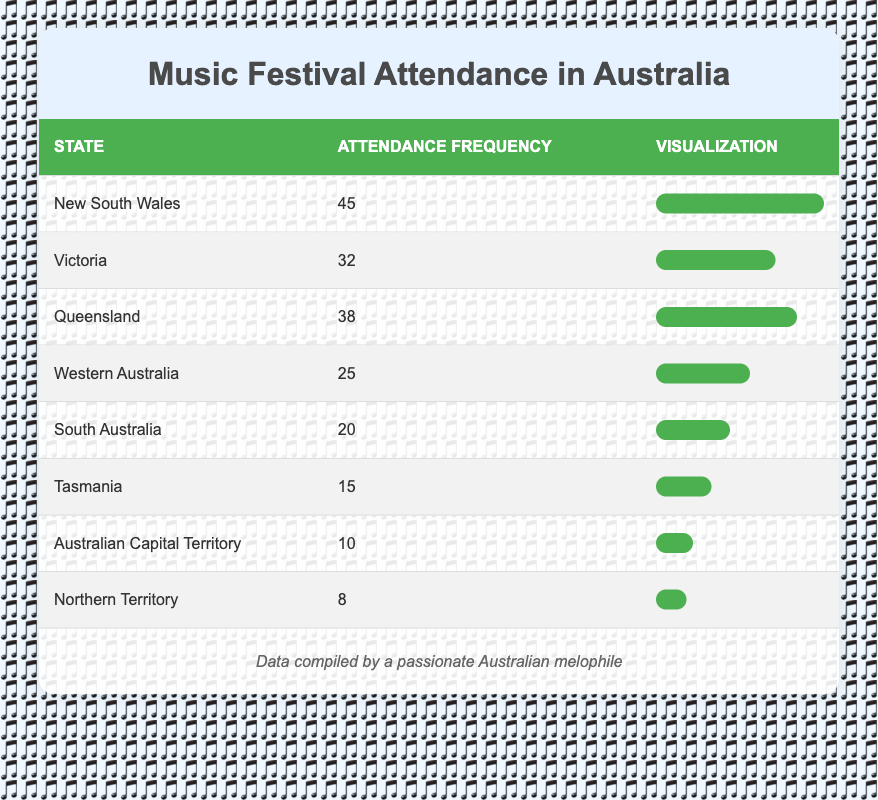What state has the highest frequency of music festival attendance? By examining the attendance frequency column, New South Wales has the highest frequency with a total of 45.
Answer: New South Wales What is the attendance frequency of Victoria? The table directly shows that the attendance frequency for Victoria is 32.
Answer: 32 Which state has the second lowest frequency of music festival attendance? The attendance frequencies from lowest to highest are: Northern Territory (8), Australian Capital Territory (10), Tasmania (15), South Australia (20), Western Australia (25), Queensland (38), Victoria (32), and New South Wales (45). The second lowest is Australian Capital Territory with an attendance of 10.
Answer: Australian Capital Territory What is the total attendance frequency of all states? To calculate the total, add all the attendance frequencies together: 45 + 32 + 38 + 25 + 20 + 15 + 10 + 8 = 193.
Answer: 193 Is it true that Queensland has a higher attendance frequency than South Australia? The frequency for Queensland is 38, and for South Australia, it's 20. Comparing these, 38 is greater than 20, confirming the statement is true.
Answer: Yes What is the average attendance frequency across all states? Calculate the average by dividing the total attendance frequency (193) by the number of states (8). So, the average is 193 / 8 = 24.125.
Answer: 24.125 How many states have an attendance frequency greater than 25? Reviewing the table, the frequencies greater than 25 are for New South Wales (45), Victoria (32), Queensland (38), and Western Australia (25). Totaling these gives us 3 states.
Answer: 3 Which two states have an attendance frequency closest to each other? By analyzing the table, the closest frequencies are for South Australia (20) and Tasmania (15), which have a difference of 5.
Answer: South Australia and Tasmania Which state has an attendance frequency that is less than 15? The table shows that Northern Territory has an attendance frequency of 8, which is less than 15.
Answer: Northern Territory 